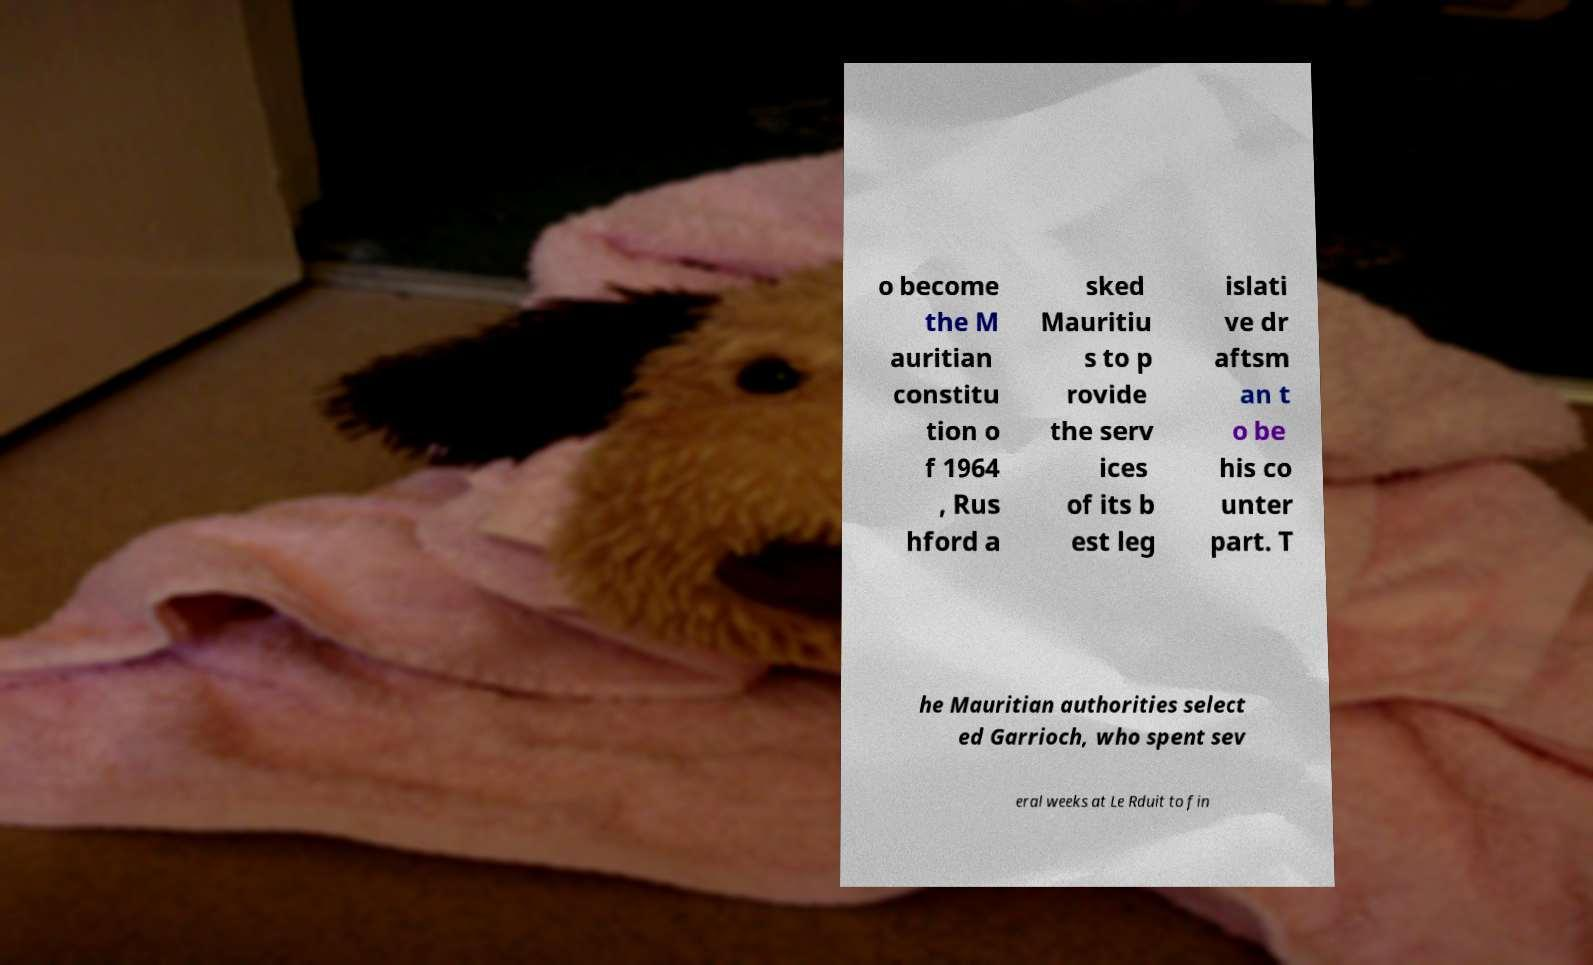There's text embedded in this image that I need extracted. Can you transcribe it verbatim? o become the M auritian constitu tion o f 1964 , Rus hford a sked Mauritiu s to p rovide the serv ices of its b est leg islati ve dr aftsm an t o be his co unter part. T he Mauritian authorities select ed Garrioch, who spent sev eral weeks at Le Rduit to fin 